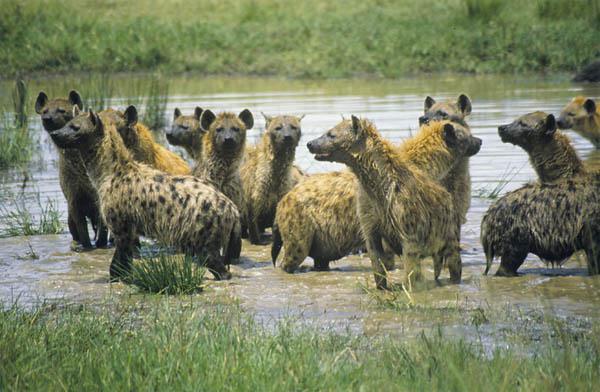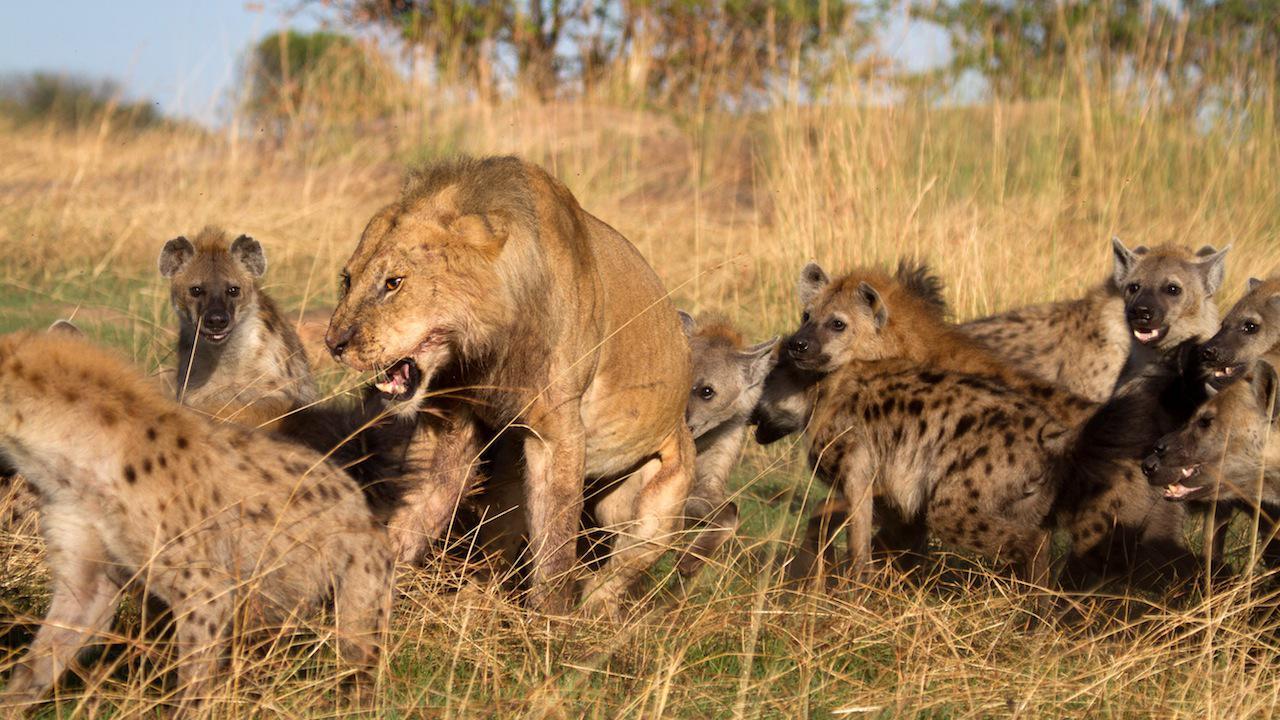The first image is the image on the left, the second image is the image on the right. Given the left and right images, does the statement "An elephant with tusks is running near a hyena." hold true? Answer yes or no. No. The first image is the image on the left, the second image is the image on the right. Analyze the images presented: Is the assertion "There is an elephant among hyenas in one of the images." valid? Answer yes or no. No. 